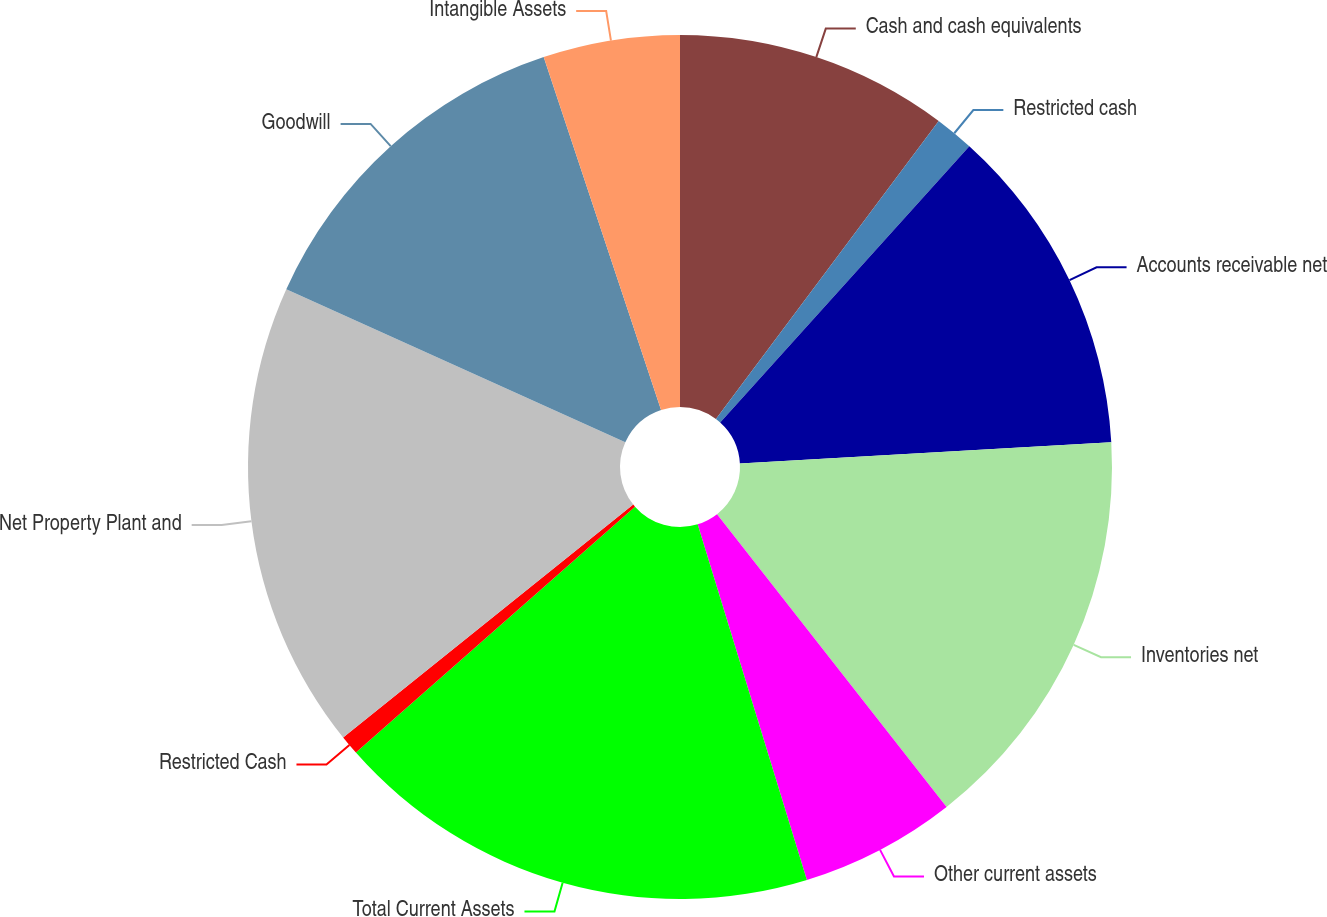Convert chart. <chart><loc_0><loc_0><loc_500><loc_500><pie_chart><fcel>Cash and cash equivalents<fcel>Restricted cash<fcel>Accounts receivable net<fcel>Inventories net<fcel>Other current assets<fcel>Total Current Assets<fcel>Restricted Cash<fcel>Net Property Plant and<fcel>Goodwill<fcel>Intangible Assets<nl><fcel>10.22%<fcel>1.46%<fcel>12.41%<fcel>15.33%<fcel>5.84%<fcel>18.25%<fcel>0.73%<fcel>17.52%<fcel>13.14%<fcel>5.11%<nl></chart> 